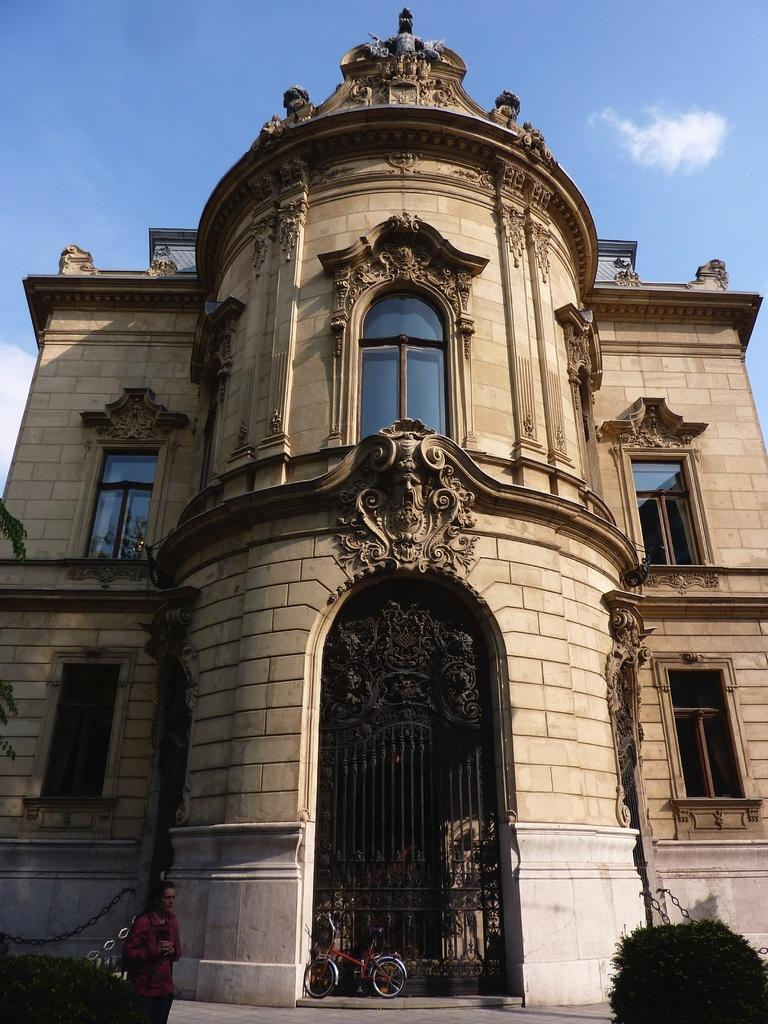What type of structure is visible in the image? There is a building in the image. What can be seen near the entrance of the building? There is a bicycle near the gate of the building. Is there anyone present in the image? Yes, there is a person in front of the building. What type of vegetation is in front of the building? There are trees in front of the building. What is visible in the background of the image? The sky is visible in the background of the image. What type of protest is happening in front of the building in the image? There is no protest visible in the image; it only shows a building, a bicycle, a person, trees, and the sky. 